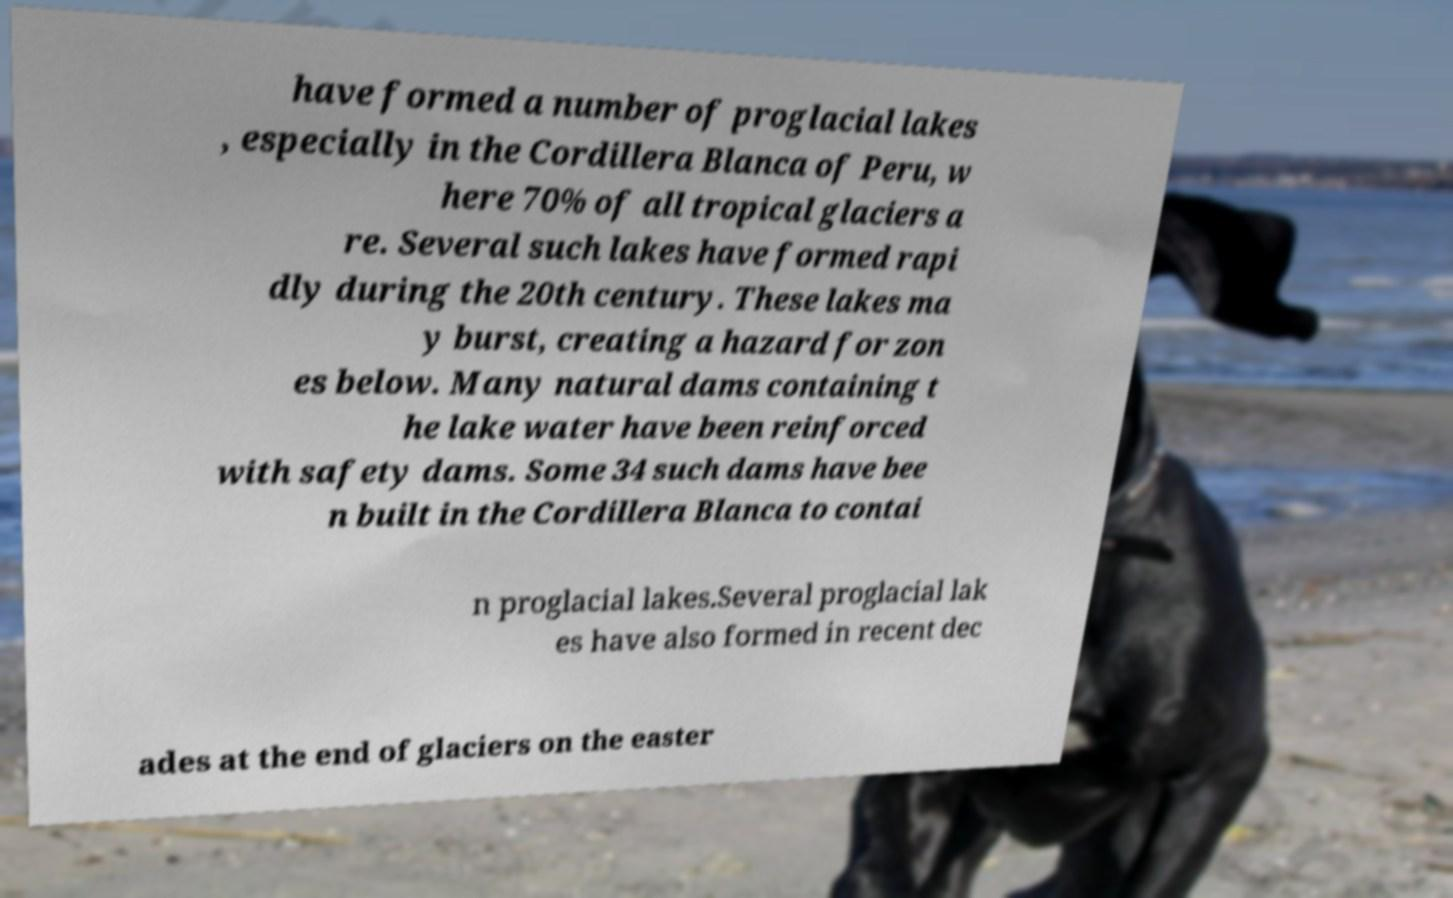Could you assist in decoding the text presented in this image and type it out clearly? have formed a number of proglacial lakes , especially in the Cordillera Blanca of Peru, w here 70% of all tropical glaciers a re. Several such lakes have formed rapi dly during the 20th century. These lakes ma y burst, creating a hazard for zon es below. Many natural dams containing t he lake water have been reinforced with safety dams. Some 34 such dams have bee n built in the Cordillera Blanca to contai n proglacial lakes.Several proglacial lak es have also formed in recent dec ades at the end of glaciers on the easter 